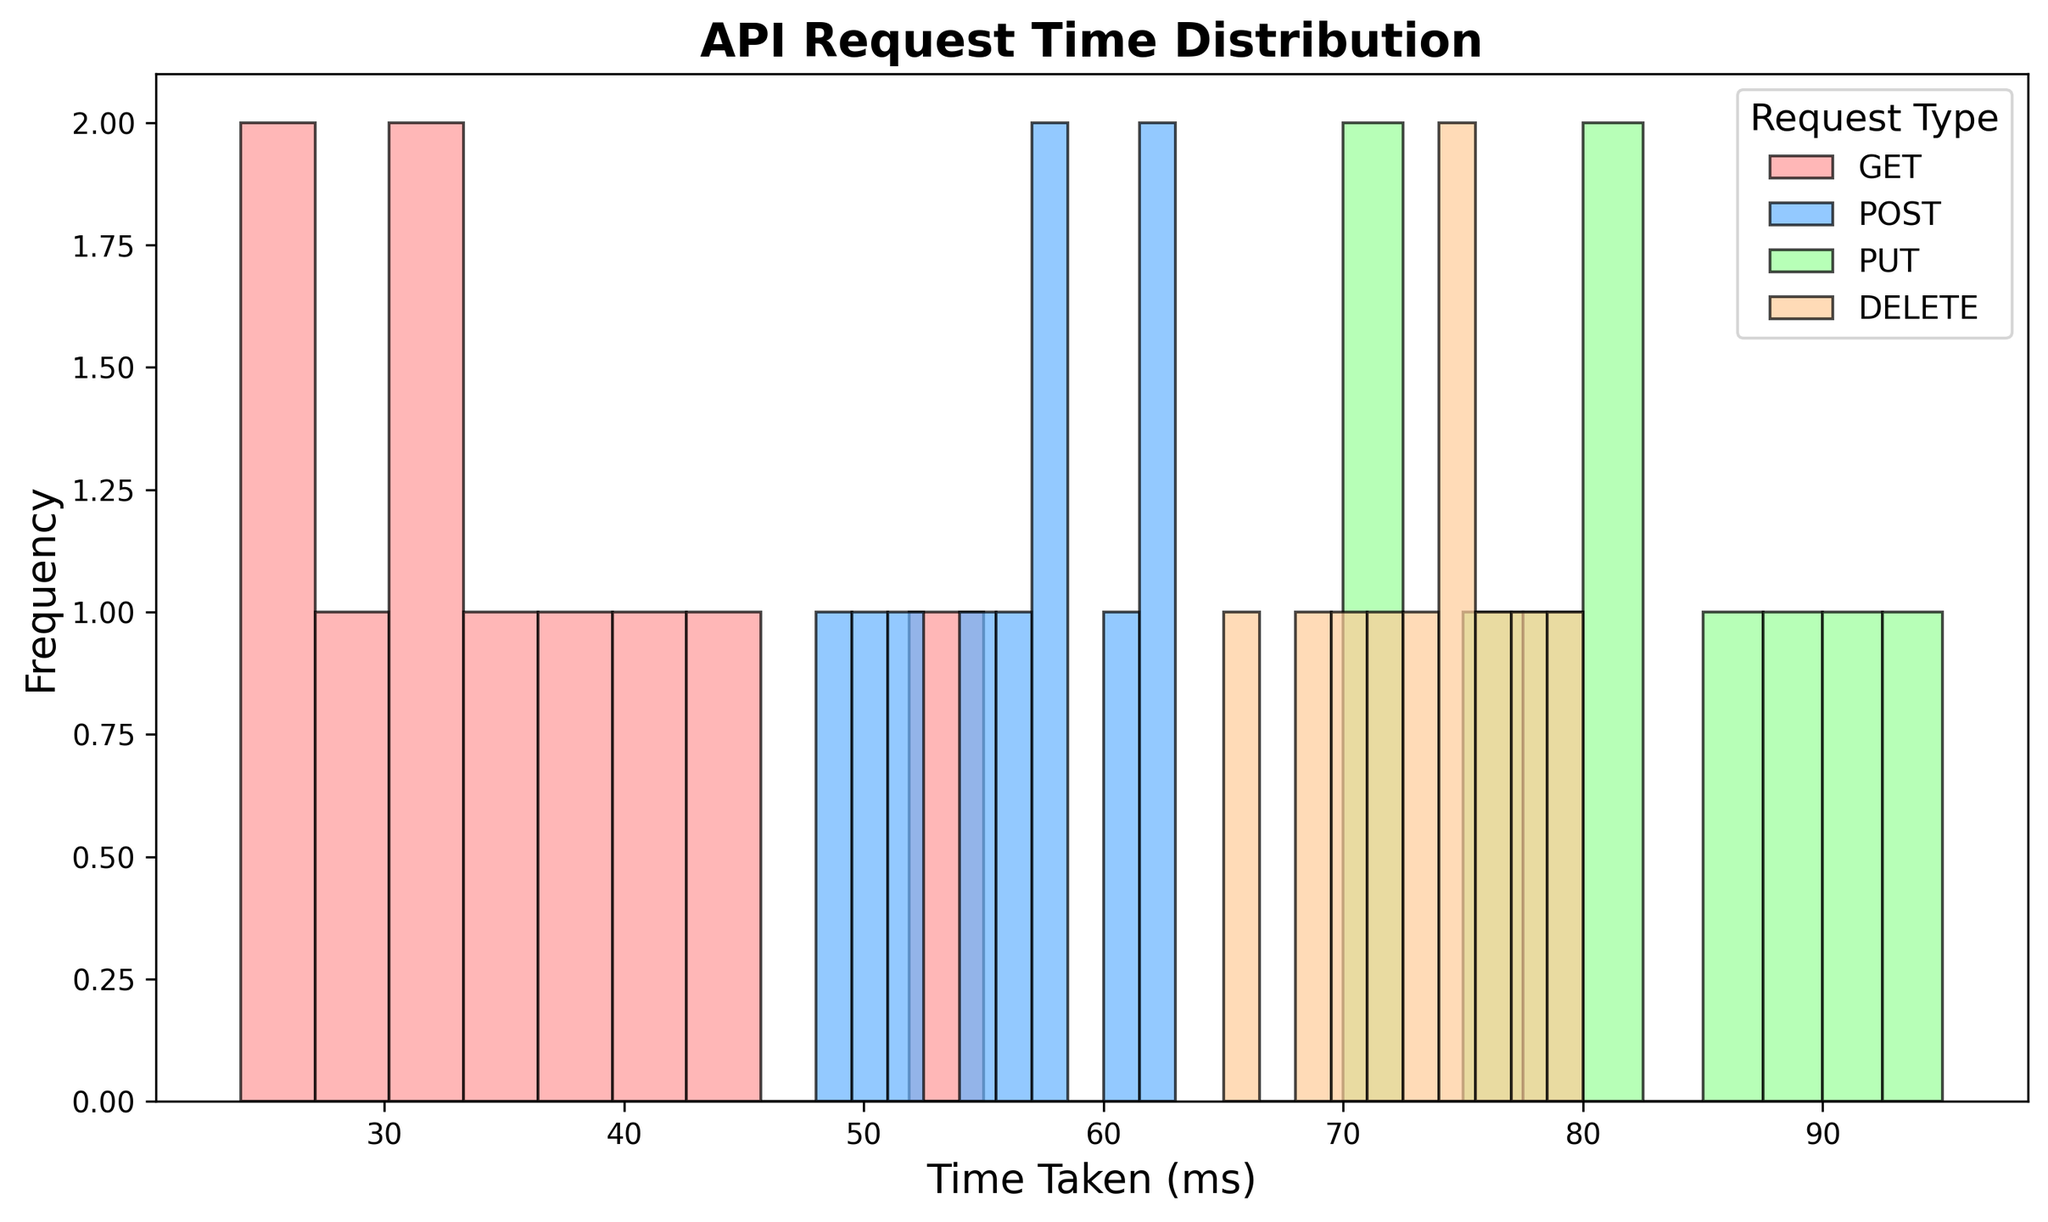What type of API request has the highest frequency at around 30ms? The histogram for GET requests shows the highest concentration around 30ms, indicated by the tallest bar among all types in that bin range. This suggests GET requests occur most frequently at this duration.
Answer: GET Which type of request has the highest spread in time taken? The PUT request type has data ranging from 70ms to 95ms, as shown by the spread of bars on the histogram representing PUT times.
Answer: PUT Between POST and DELETE requests, which has a higher median time taken? The middle data point for POST requests is around 56ms, while for DELETE requests, it is around 72ms. This can be inferred by evaluating the distribution of the bars in each histogram segment.
Answer: DELETE What is the approximate difference in the average time taken between GET and PUT requests? The average time for GET is roughly (24+35+45+28+40+32+27+55+38+31)/10 = 35ms. For PUT, it is (70+80+75+90+85+95+78+88+72+82)/10 = 81.5ms. Subtract the two averages to get 81.5 - 35 = 46.5ms.
Answer: 46.5ms Which API request type has the highest peak frequency for time taken? PUT and DELETE request types have high peaks, but PUT requests have a taller peak around the region of 80ms compared to the other types.
Answer: PUT What is the range of times taken for DELETE requests? The range is calculated as the maximum time (80ms) minus the minimum time (65ms), as indicated by the start and end of the bars for DELETE requests.
Answer: 15ms Among GET, POST, PUT, and DELETE requests, which two types have the closest average times taken? The average time for GET is around 35ms and for POST it’s around 56ms. For PUT it's about 81.5ms, and for DELETE it’s approximately (65+70+68+75+72+74+77+73+80+76)/10 = 73ms. The closest averages are between POST and DELETE (56ms and 73ms).
Answer: POST and DELETE 